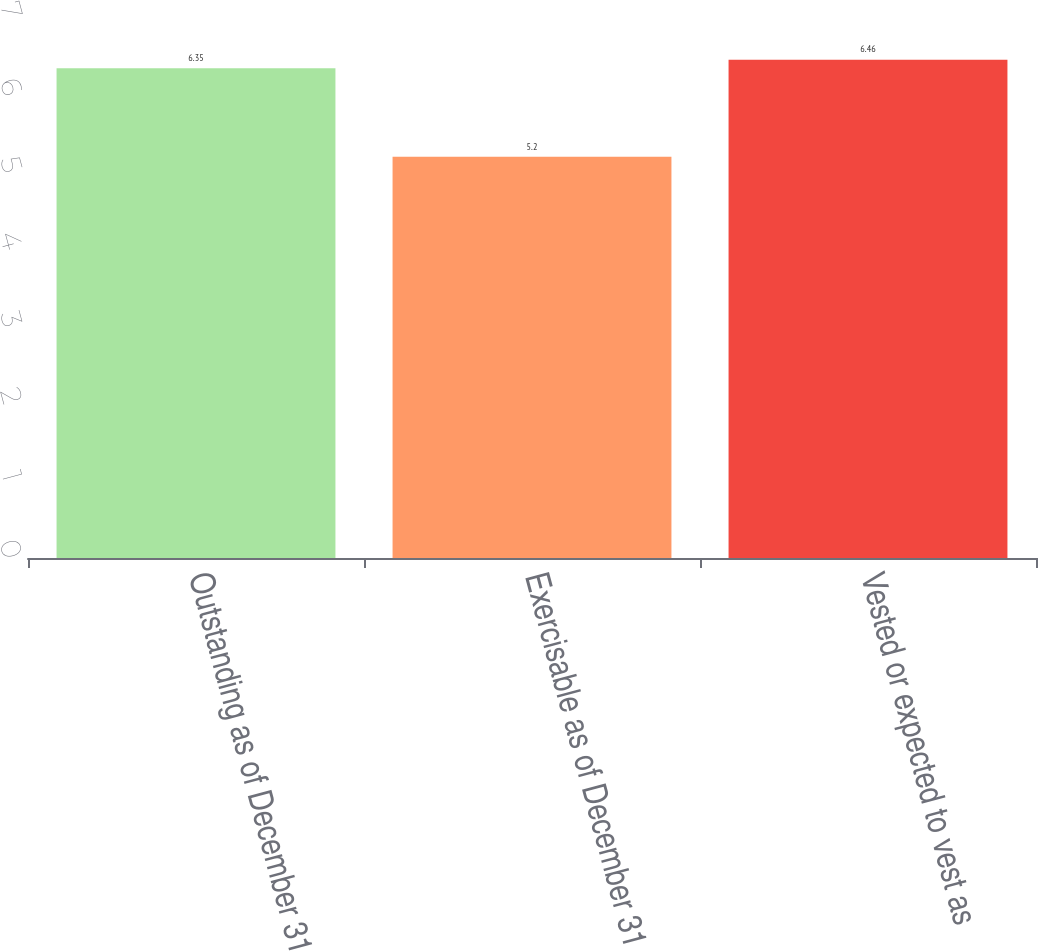Convert chart. <chart><loc_0><loc_0><loc_500><loc_500><bar_chart><fcel>Outstanding as of December 31<fcel>Exercisable as of December 31<fcel>Vested or expected to vest as<nl><fcel>6.35<fcel>5.2<fcel>6.46<nl></chart> 